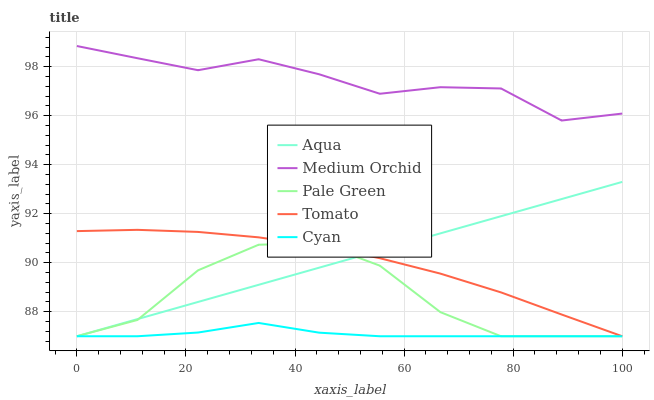Does Cyan have the minimum area under the curve?
Answer yes or no. Yes. Does Medium Orchid have the maximum area under the curve?
Answer yes or no. Yes. Does Pale Green have the minimum area under the curve?
Answer yes or no. No. Does Pale Green have the maximum area under the curve?
Answer yes or no. No. Is Aqua the smoothest?
Answer yes or no. Yes. Is Pale Green the roughest?
Answer yes or no. Yes. Is Medium Orchid the smoothest?
Answer yes or no. No. Is Medium Orchid the roughest?
Answer yes or no. No. Does Medium Orchid have the lowest value?
Answer yes or no. No. Does Pale Green have the highest value?
Answer yes or no. No. Is Tomato less than Medium Orchid?
Answer yes or no. Yes. Is Medium Orchid greater than Aqua?
Answer yes or no. Yes. Does Tomato intersect Medium Orchid?
Answer yes or no. No. 